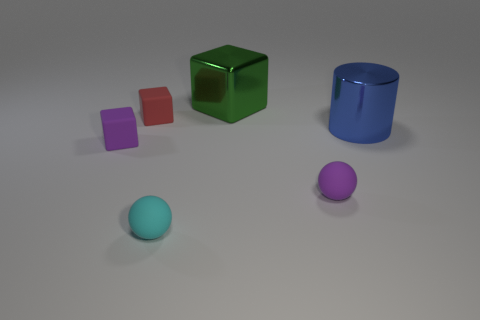Subtract all tiny purple cubes. How many cubes are left? 2 Add 1 green matte cylinders. How many objects exist? 7 Subtract 1 cubes. How many cubes are left? 2 Subtract all cylinders. How many objects are left? 5 Subtract all cyan metal blocks. Subtract all green things. How many objects are left? 5 Add 6 green blocks. How many green blocks are left? 7 Add 1 metallic things. How many metallic things exist? 3 Subtract 0 blue spheres. How many objects are left? 6 Subtract all green cubes. Subtract all cyan cylinders. How many cubes are left? 2 